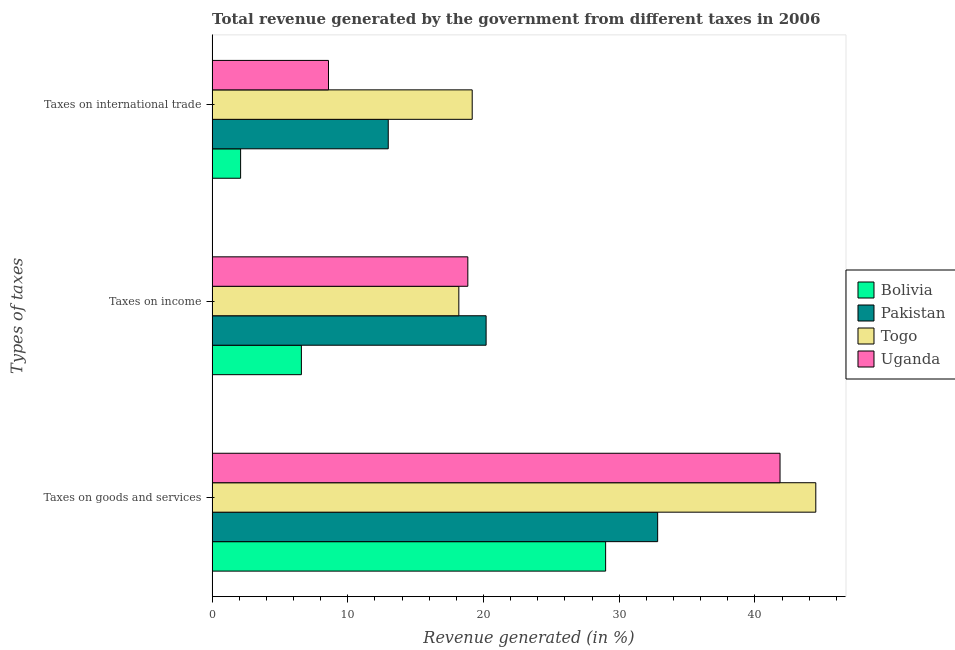How many bars are there on the 2nd tick from the top?
Offer a very short reply. 4. How many bars are there on the 1st tick from the bottom?
Offer a terse response. 4. What is the label of the 2nd group of bars from the top?
Your answer should be very brief. Taxes on income. What is the percentage of revenue generated by taxes on income in Pakistan?
Make the answer very short. 20.19. Across all countries, what is the maximum percentage of revenue generated by taxes on goods and services?
Provide a short and direct response. 44.49. Across all countries, what is the minimum percentage of revenue generated by taxes on income?
Ensure brevity in your answer.  6.58. In which country was the percentage of revenue generated by taxes on income minimum?
Your response must be concise. Bolivia. What is the total percentage of revenue generated by tax on international trade in the graph?
Offer a very short reply. 42.82. What is the difference between the percentage of revenue generated by tax on international trade in Bolivia and that in Pakistan?
Give a very brief answer. -10.88. What is the difference between the percentage of revenue generated by tax on international trade in Togo and the percentage of revenue generated by taxes on income in Bolivia?
Ensure brevity in your answer.  12.59. What is the average percentage of revenue generated by taxes on income per country?
Make the answer very short. 15.95. What is the difference between the percentage of revenue generated by taxes on goods and services and percentage of revenue generated by taxes on income in Togo?
Keep it short and to the point. 26.31. What is the ratio of the percentage of revenue generated by tax on international trade in Bolivia to that in Togo?
Your answer should be compact. 0.11. Is the percentage of revenue generated by tax on international trade in Pakistan less than that in Togo?
Keep it short and to the point. Yes. Is the difference between the percentage of revenue generated by tax on international trade in Togo and Bolivia greater than the difference between the percentage of revenue generated by taxes on income in Togo and Bolivia?
Make the answer very short. Yes. What is the difference between the highest and the second highest percentage of revenue generated by taxes on goods and services?
Your response must be concise. 2.63. What is the difference between the highest and the lowest percentage of revenue generated by taxes on goods and services?
Keep it short and to the point. 15.49. Is the sum of the percentage of revenue generated by tax on international trade in Uganda and Togo greater than the maximum percentage of revenue generated by taxes on goods and services across all countries?
Your answer should be compact. No. What does the 1st bar from the bottom in Taxes on goods and services represents?
Your response must be concise. Bolivia. How many bars are there?
Offer a terse response. 12. Are the values on the major ticks of X-axis written in scientific E-notation?
Offer a terse response. No. Does the graph contain any zero values?
Provide a succinct answer. No. How many legend labels are there?
Keep it short and to the point. 4. How are the legend labels stacked?
Give a very brief answer. Vertical. What is the title of the graph?
Provide a succinct answer. Total revenue generated by the government from different taxes in 2006. Does "Korea (Republic)" appear as one of the legend labels in the graph?
Make the answer very short. No. What is the label or title of the X-axis?
Provide a short and direct response. Revenue generated (in %). What is the label or title of the Y-axis?
Keep it short and to the point. Types of taxes. What is the Revenue generated (in %) in Bolivia in Taxes on goods and services?
Ensure brevity in your answer.  29. What is the Revenue generated (in %) of Pakistan in Taxes on goods and services?
Provide a short and direct response. 32.83. What is the Revenue generated (in %) in Togo in Taxes on goods and services?
Ensure brevity in your answer.  44.49. What is the Revenue generated (in %) in Uganda in Taxes on goods and services?
Ensure brevity in your answer.  41.85. What is the Revenue generated (in %) in Bolivia in Taxes on income?
Offer a very short reply. 6.58. What is the Revenue generated (in %) in Pakistan in Taxes on income?
Keep it short and to the point. 20.19. What is the Revenue generated (in %) in Togo in Taxes on income?
Your answer should be very brief. 18.18. What is the Revenue generated (in %) of Uganda in Taxes on income?
Make the answer very short. 18.84. What is the Revenue generated (in %) of Bolivia in Taxes on international trade?
Make the answer very short. 2.1. What is the Revenue generated (in %) of Pakistan in Taxes on international trade?
Give a very brief answer. 12.98. What is the Revenue generated (in %) in Togo in Taxes on international trade?
Provide a short and direct response. 19.17. What is the Revenue generated (in %) of Uganda in Taxes on international trade?
Offer a terse response. 8.58. Across all Types of taxes, what is the maximum Revenue generated (in %) of Bolivia?
Ensure brevity in your answer.  29. Across all Types of taxes, what is the maximum Revenue generated (in %) in Pakistan?
Make the answer very short. 32.83. Across all Types of taxes, what is the maximum Revenue generated (in %) of Togo?
Keep it short and to the point. 44.49. Across all Types of taxes, what is the maximum Revenue generated (in %) of Uganda?
Offer a very short reply. 41.85. Across all Types of taxes, what is the minimum Revenue generated (in %) in Bolivia?
Provide a short and direct response. 2.1. Across all Types of taxes, what is the minimum Revenue generated (in %) of Pakistan?
Provide a short and direct response. 12.98. Across all Types of taxes, what is the minimum Revenue generated (in %) of Togo?
Make the answer very short. 18.18. Across all Types of taxes, what is the minimum Revenue generated (in %) in Uganda?
Keep it short and to the point. 8.58. What is the total Revenue generated (in %) in Bolivia in the graph?
Give a very brief answer. 37.68. What is the total Revenue generated (in %) of Pakistan in the graph?
Keep it short and to the point. 66. What is the total Revenue generated (in %) of Togo in the graph?
Make the answer very short. 81.83. What is the total Revenue generated (in %) of Uganda in the graph?
Keep it short and to the point. 69.27. What is the difference between the Revenue generated (in %) in Bolivia in Taxes on goods and services and that in Taxes on income?
Your response must be concise. 22.42. What is the difference between the Revenue generated (in %) in Pakistan in Taxes on goods and services and that in Taxes on income?
Your answer should be very brief. 12.64. What is the difference between the Revenue generated (in %) in Togo in Taxes on goods and services and that in Taxes on income?
Your response must be concise. 26.31. What is the difference between the Revenue generated (in %) of Uganda in Taxes on goods and services and that in Taxes on income?
Keep it short and to the point. 23.01. What is the difference between the Revenue generated (in %) of Bolivia in Taxes on goods and services and that in Taxes on international trade?
Your answer should be very brief. 26.9. What is the difference between the Revenue generated (in %) of Pakistan in Taxes on goods and services and that in Taxes on international trade?
Ensure brevity in your answer.  19.85. What is the difference between the Revenue generated (in %) in Togo in Taxes on goods and services and that in Taxes on international trade?
Make the answer very short. 25.32. What is the difference between the Revenue generated (in %) in Uganda in Taxes on goods and services and that in Taxes on international trade?
Your response must be concise. 33.28. What is the difference between the Revenue generated (in %) in Bolivia in Taxes on income and that in Taxes on international trade?
Your response must be concise. 4.48. What is the difference between the Revenue generated (in %) of Pakistan in Taxes on income and that in Taxes on international trade?
Offer a very short reply. 7.21. What is the difference between the Revenue generated (in %) in Togo in Taxes on income and that in Taxes on international trade?
Your response must be concise. -0.99. What is the difference between the Revenue generated (in %) of Uganda in Taxes on income and that in Taxes on international trade?
Keep it short and to the point. 10.27. What is the difference between the Revenue generated (in %) in Bolivia in Taxes on goods and services and the Revenue generated (in %) in Pakistan in Taxes on income?
Provide a short and direct response. 8.81. What is the difference between the Revenue generated (in %) in Bolivia in Taxes on goods and services and the Revenue generated (in %) in Togo in Taxes on income?
Give a very brief answer. 10.82. What is the difference between the Revenue generated (in %) in Bolivia in Taxes on goods and services and the Revenue generated (in %) in Uganda in Taxes on income?
Offer a terse response. 10.15. What is the difference between the Revenue generated (in %) of Pakistan in Taxes on goods and services and the Revenue generated (in %) of Togo in Taxes on income?
Offer a very short reply. 14.65. What is the difference between the Revenue generated (in %) of Pakistan in Taxes on goods and services and the Revenue generated (in %) of Uganda in Taxes on income?
Provide a short and direct response. 13.99. What is the difference between the Revenue generated (in %) of Togo in Taxes on goods and services and the Revenue generated (in %) of Uganda in Taxes on income?
Give a very brief answer. 25.64. What is the difference between the Revenue generated (in %) of Bolivia in Taxes on goods and services and the Revenue generated (in %) of Pakistan in Taxes on international trade?
Ensure brevity in your answer.  16.02. What is the difference between the Revenue generated (in %) in Bolivia in Taxes on goods and services and the Revenue generated (in %) in Togo in Taxes on international trade?
Keep it short and to the point. 9.83. What is the difference between the Revenue generated (in %) in Bolivia in Taxes on goods and services and the Revenue generated (in %) in Uganda in Taxes on international trade?
Ensure brevity in your answer.  20.42. What is the difference between the Revenue generated (in %) in Pakistan in Taxes on goods and services and the Revenue generated (in %) in Togo in Taxes on international trade?
Make the answer very short. 13.67. What is the difference between the Revenue generated (in %) of Pakistan in Taxes on goods and services and the Revenue generated (in %) of Uganda in Taxes on international trade?
Provide a succinct answer. 24.26. What is the difference between the Revenue generated (in %) in Togo in Taxes on goods and services and the Revenue generated (in %) in Uganda in Taxes on international trade?
Provide a succinct answer. 35.91. What is the difference between the Revenue generated (in %) in Bolivia in Taxes on income and the Revenue generated (in %) in Pakistan in Taxes on international trade?
Offer a terse response. -6.4. What is the difference between the Revenue generated (in %) of Bolivia in Taxes on income and the Revenue generated (in %) of Togo in Taxes on international trade?
Give a very brief answer. -12.59. What is the difference between the Revenue generated (in %) in Bolivia in Taxes on income and the Revenue generated (in %) in Uganda in Taxes on international trade?
Ensure brevity in your answer.  -2. What is the difference between the Revenue generated (in %) of Pakistan in Taxes on income and the Revenue generated (in %) of Togo in Taxes on international trade?
Your answer should be very brief. 1.02. What is the difference between the Revenue generated (in %) of Pakistan in Taxes on income and the Revenue generated (in %) of Uganda in Taxes on international trade?
Your response must be concise. 11.62. What is the difference between the Revenue generated (in %) of Togo in Taxes on income and the Revenue generated (in %) of Uganda in Taxes on international trade?
Your answer should be very brief. 9.61. What is the average Revenue generated (in %) of Bolivia per Types of taxes?
Offer a terse response. 12.56. What is the average Revenue generated (in %) of Pakistan per Types of taxes?
Provide a short and direct response. 22. What is the average Revenue generated (in %) of Togo per Types of taxes?
Your answer should be very brief. 27.28. What is the average Revenue generated (in %) in Uganda per Types of taxes?
Your answer should be very brief. 23.09. What is the difference between the Revenue generated (in %) of Bolivia and Revenue generated (in %) of Pakistan in Taxes on goods and services?
Ensure brevity in your answer.  -3.83. What is the difference between the Revenue generated (in %) in Bolivia and Revenue generated (in %) in Togo in Taxes on goods and services?
Your answer should be very brief. -15.49. What is the difference between the Revenue generated (in %) of Bolivia and Revenue generated (in %) of Uganda in Taxes on goods and services?
Your response must be concise. -12.85. What is the difference between the Revenue generated (in %) in Pakistan and Revenue generated (in %) in Togo in Taxes on goods and services?
Your answer should be compact. -11.65. What is the difference between the Revenue generated (in %) in Pakistan and Revenue generated (in %) in Uganda in Taxes on goods and services?
Offer a very short reply. -9.02. What is the difference between the Revenue generated (in %) of Togo and Revenue generated (in %) of Uganda in Taxes on goods and services?
Your response must be concise. 2.63. What is the difference between the Revenue generated (in %) in Bolivia and Revenue generated (in %) in Pakistan in Taxes on income?
Provide a succinct answer. -13.61. What is the difference between the Revenue generated (in %) of Bolivia and Revenue generated (in %) of Togo in Taxes on income?
Keep it short and to the point. -11.6. What is the difference between the Revenue generated (in %) of Bolivia and Revenue generated (in %) of Uganda in Taxes on income?
Your answer should be compact. -12.27. What is the difference between the Revenue generated (in %) in Pakistan and Revenue generated (in %) in Togo in Taxes on income?
Provide a short and direct response. 2.01. What is the difference between the Revenue generated (in %) of Pakistan and Revenue generated (in %) of Uganda in Taxes on income?
Your response must be concise. 1.35. What is the difference between the Revenue generated (in %) of Togo and Revenue generated (in %) of Uganda in Taxes on income?
Your answer should be very brief. -0.66. What is the difference between the Revenue generated (in %) in Bolivia and Revenue generated (in %) in Pakistan in Taxes on international trade?
Keep it short and to the point. -10.88. What is the difference between the Revenue generated (in %) of Bolivia and Revenue generated (in %) of Togo in Taxes on international trade?
Keep it short and to the point. -17.07. What is the difference between the Revenue generated (in %) in Bolivia and Revenue generated (in %) in Uganda in Taxes on international trade?
Make the answer very short. -6.48. What is the difference between the Revenue generated (in %) in Pakistan and Revenue generated (in %) in Togo in Taxes on international trade?
Make the answer very short. -6.19. What is the difference between the Revenue generated (in %) of Pakistan and Revenue generated (in %) of Uganda in Taxes on international trade?
Offer a very short reply. 4.4. What is the difference between the Revenue generated (in %) of Togo and Revenue generated (in %) of Uganda in Taxes on international trade?
Your answer should be compact. 10.59. What is the ratio of the Revenue generated (in %) of Bolivia in Taxes on goods and services to that in Taxes on income?
Your answer should be compact. 4.41. What is the ratio of the Revenue generated (in %) in Pakistan in Taxes on goods and services to that in Taxes on income?
Provide a succinct answer. 1.63. What is the ratio of the Revenue generated (in %) of Togo in Taxes on goods and services to that in Taxes on income?
Provide a succinct answer. 2.45. What is the ratio of the Revenue generated (in %) of Uganda in Taxes on goods and services to that in Taxes on income?
Keep it short and to the point. 2.22. What is the ratio of the Revenue generated (in %) in Bolivia in Taxes on goods and services to that in Taxes on international trade?
Your response must be concise. 13.81. What is the ratio of the Revenue generated (in %) of Pakistan in Taxes on goods and services to that in Taxes on international trade?
Keep it short and to the point. 2.53. What is the ratio of the Revenue generated (in %) of Togo in Taxes on goods and services to that in Taxes on international trade?
Your answer should be very brief. 2.32. What is the ratio of the Revenue generated (in %) of Uganda in Taxes on goods and services to that in Taxes on international trade?
Give a very brief answer. 4.88. What is the ratio of the Revenue generated (in %) in Bolivia in Taxes on income to that in Taxes on international trade?
Make the answer very short. 3.13. What is the ratio of the Revenue generated (in %) in Pakistan in Taxes on income to that in Taxes on international trade?
Provide a short and direct response. 1.56. What is the ratio of the Revenue generated (in %) of Togo in Taxes on income to that in Taxes on international trade?
Ensure brevity in your answer.  0.95. What is the ratio of the Revenue generated (in %) of Uganda in Taxes on income to that in Taxes on international trade?
Keep it short and to the point. 2.2. What is the difference between the highest and the second highest Revenue generated (in %) of Bolivia?
Give a very brief answer. 22.42. What is the difference between the highest and the second highest Revenue generated (in %) of Pakistan?
Provide a succinct answer. 12.64. What is the difference between the highest and the second highest Revenue generated (in %) in Togo?
Offer a terse response. 25.32. What is the difference between the highest and the second highest Revenue generated (in %) in Uganda?
Keep it short and to the point. 23.01. What is the difference between the highest and the lowest Revenue generated (in %) in Bolivia?
Your answer should be compact. 26.9. What is the difference between the highest and the lowest Revenue generated (in %) of Pakistan?
Offer a terse response. 19.85. What is the difference between the highest and the lowest Revenue generated (in %) of Togo?
Give a very brief answer. 26.31. What is the difference between the highest and the lowest Revenue generated (in %) in Uganda?
Your answer should be compact. 33.28. 